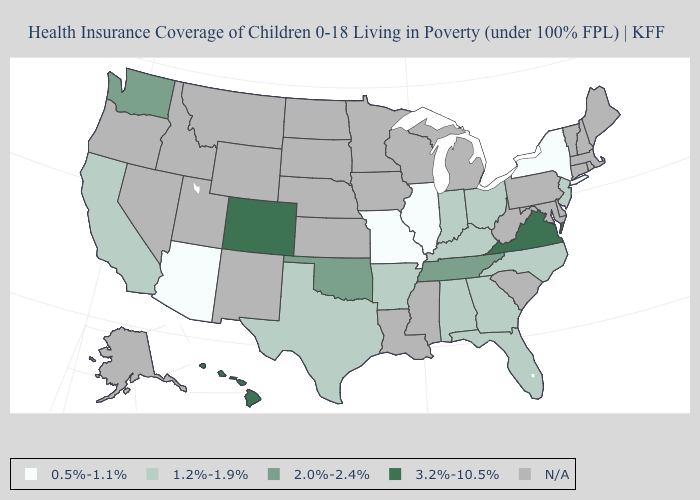Does the map have missing data?
Answer briefly. Yes. Name the states that have a value in the range 1.2%-1.9%?
Short answer required. Alabama, Arkansas, California, Florida, Georgia, Indiana, Kentucky, New Jersey, North Carolina, Ohio, Texas. What is the value of Colorado?
Concise answer only. 3.2%-10.5%. Does the map have missing data?
Give a very brief answer. Yes. What is the value of Alabama?
Write a very short answer. 1.2%-1.9%. Name the states that have a value in the range 0.5%-1.1%?
Keep it brief. Arizona, Illinois, Missouri, New York. Does Arkansas have the lowest value in the South?
Give a very brief answer. Yes. Does New Jersey have the highest value in the Northeast?
Concise answer only. Yes. Name the states that have a value in the range 0.5%-1.1%?
Concise answer only. Arizona, Illinois, Missouri, New York. Does Tennessee have the highest value in the USA?
Write a very short answer. No. Which states have the highest value in the USA?
Write a very short answer. Colorado, Hawaii, Virginia. Does the map have missing data?
Keep it brief. Yes. 